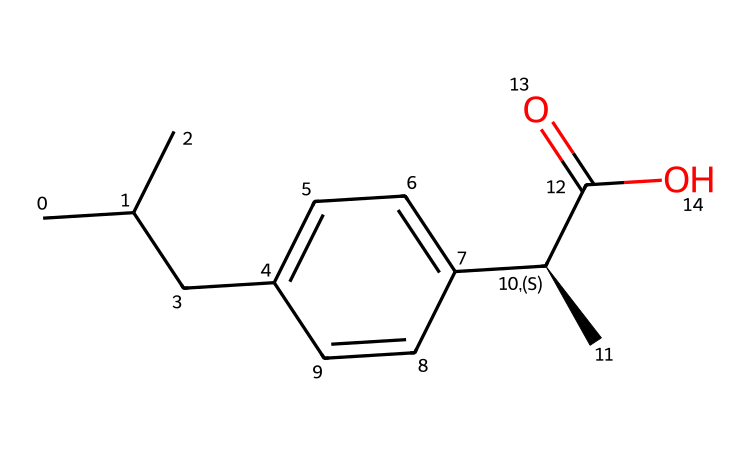What is the chemical name of this compound? The provided SMILES representation corresponds to ibuprofen, which is an over-the-counter pain reliever commonly used.
Answer: ibuprofen How many carbon atoms are present in ibuprofen? By analyzing the SMILES structure, we identify a total of 13 carbon atoms (C). Each 'C' in the SMILES string represents a carbon atom.
Answer: 13 What type of functional group is present in ibuprofen? The structure displays a carboxylic acid functional group (C(=O)O), identifiable by the presence of the -COOH group at the end of the carbon chain.
Answer: carboxylic acid What is the total number of double bonds present in ibuprofen? In the structure, there is one double bond (the C=O in the carboxylic acid group), making it necessary to count that to find the total number of double bonds in the molecule.
Answer: 1 Is ibuprofen a saturated or unsaturated compound? The presence of a double bond indicates that ibuprofen is unsaturated. Saturated compounds contain only single bonds, while unsaturated compounds have at least one double or triple bond.
Answer: unsaturated Which part of ibuprofen structure provides its analgesic properties? The presence of the carboxylic acid functional group (C(=O)O) is essential for the biological activity of ibuprofen, as this functional group plays a crucial role in the inhibition of cyclooxygenase enzymes responsible for pain signaling.
Answer: carboxylic acid 